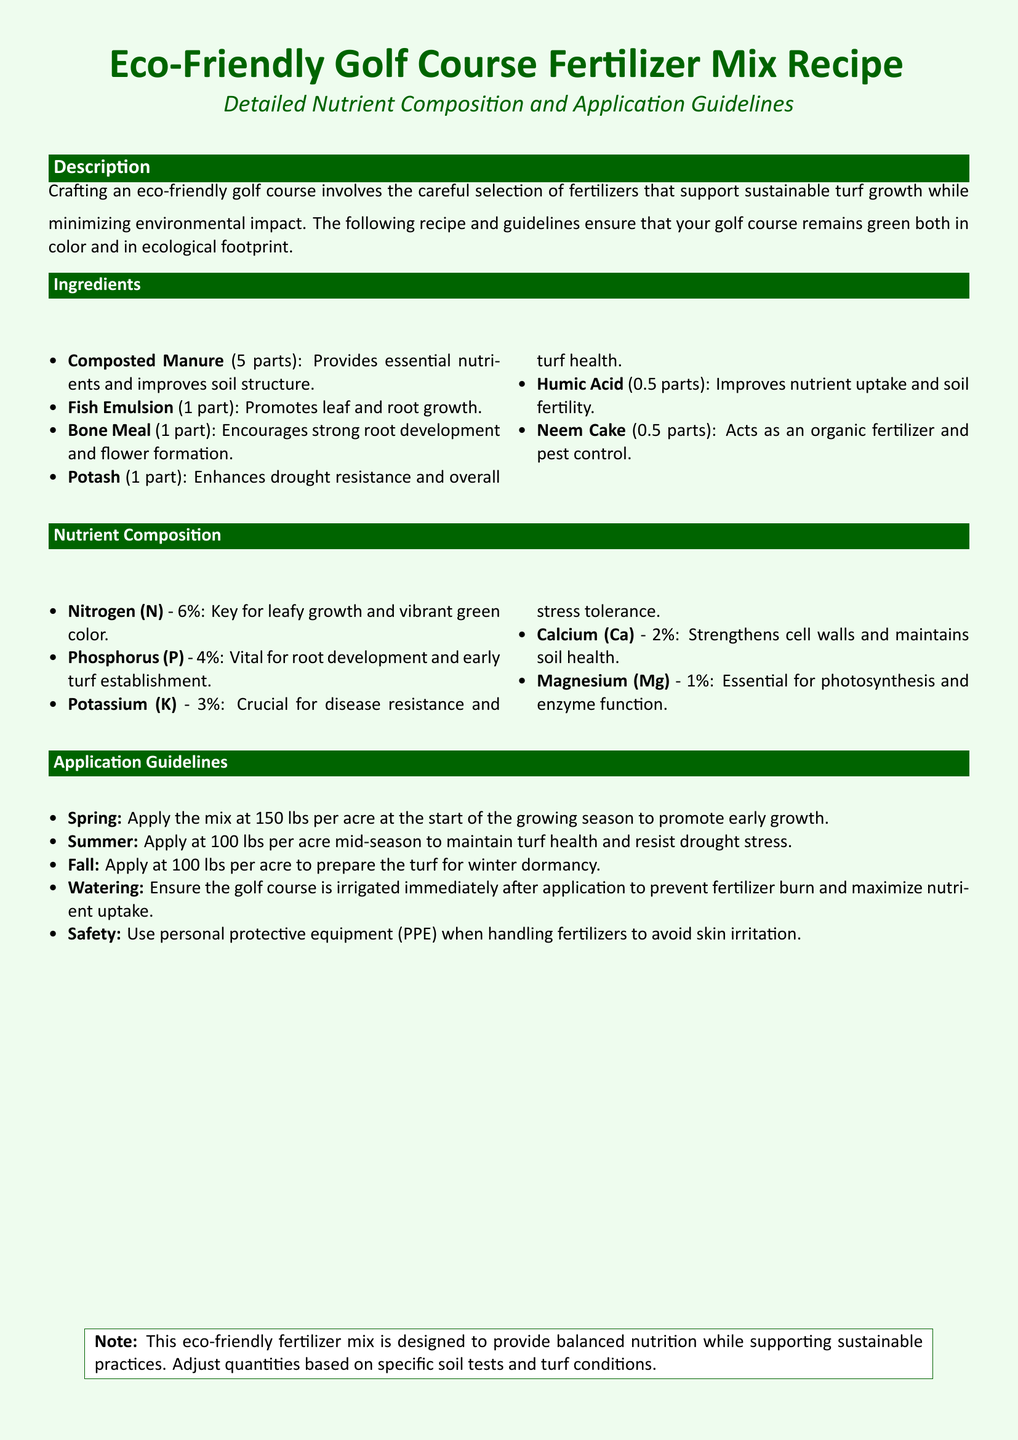What is the primary ingredient in the eco-friendly fertilizer mix? The primary ingredient is composted manure, which is listed first in the ingredients section.
Answer: Composted Manure How much potash is included in the mixture? Potash is specified to be one part in the ingredients list.
Answer: 1 part What is the nitrogen percentage in the nutrient composition? The nutrient composition section provides that nitrogen is at 6 percent.
Answer: 6% What is the recommended application rate for spring? The application guidelines state to use 150 lbs per acre in spring.
Answer: 150 lbs per acre What is the purpose of added neem cake? The document states neem cake acts as an organic fertilizer and pest control, fulfilling specific roles in the mix.
Answer: Organic fertilizer and pest control How often should watering occur after fertilizer application? The application guidelines emphasize that irrigation should occur immediately after applying the fertilizer.
Answer: Immediately What safety precaution is mentioned in the document? The document mentions using personal protective equipment when handling fertilizers to avoid skin irritation.
Answer: Personal protective equipment What is the purpose of humic acid in the fertilizer mix? Humic acid is stated to improve nutrient uptake and soil fertility in the nutrients list.
Answer: Improves nutrient uptake and soil fertility 